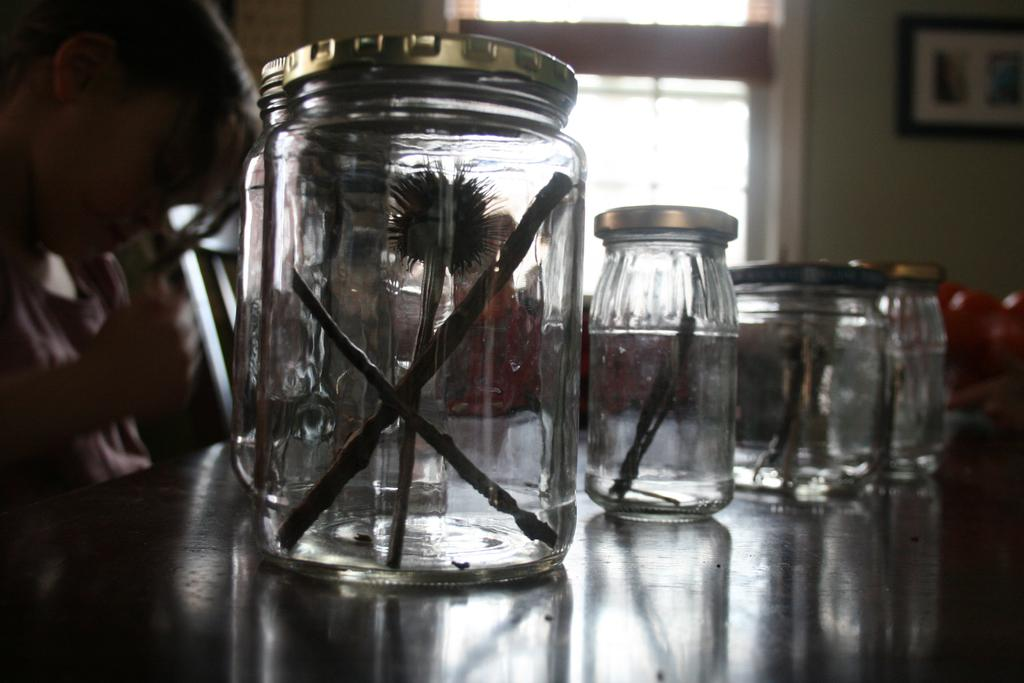What can be seen on the table in the image? There are jars placed on the table. What is on top of each jar? There is an object on each jar. Can you describe the person on the left side of the image? The person is holding a pen. What is visible on the wall in the image? There is a window on the wall. What type of plantation can be seen through the window in the image? There is no plantation visible through the window in the image. How does the person adjust the pen in the image? The person is not adjusting the pen in the image; they are simply holding it. 